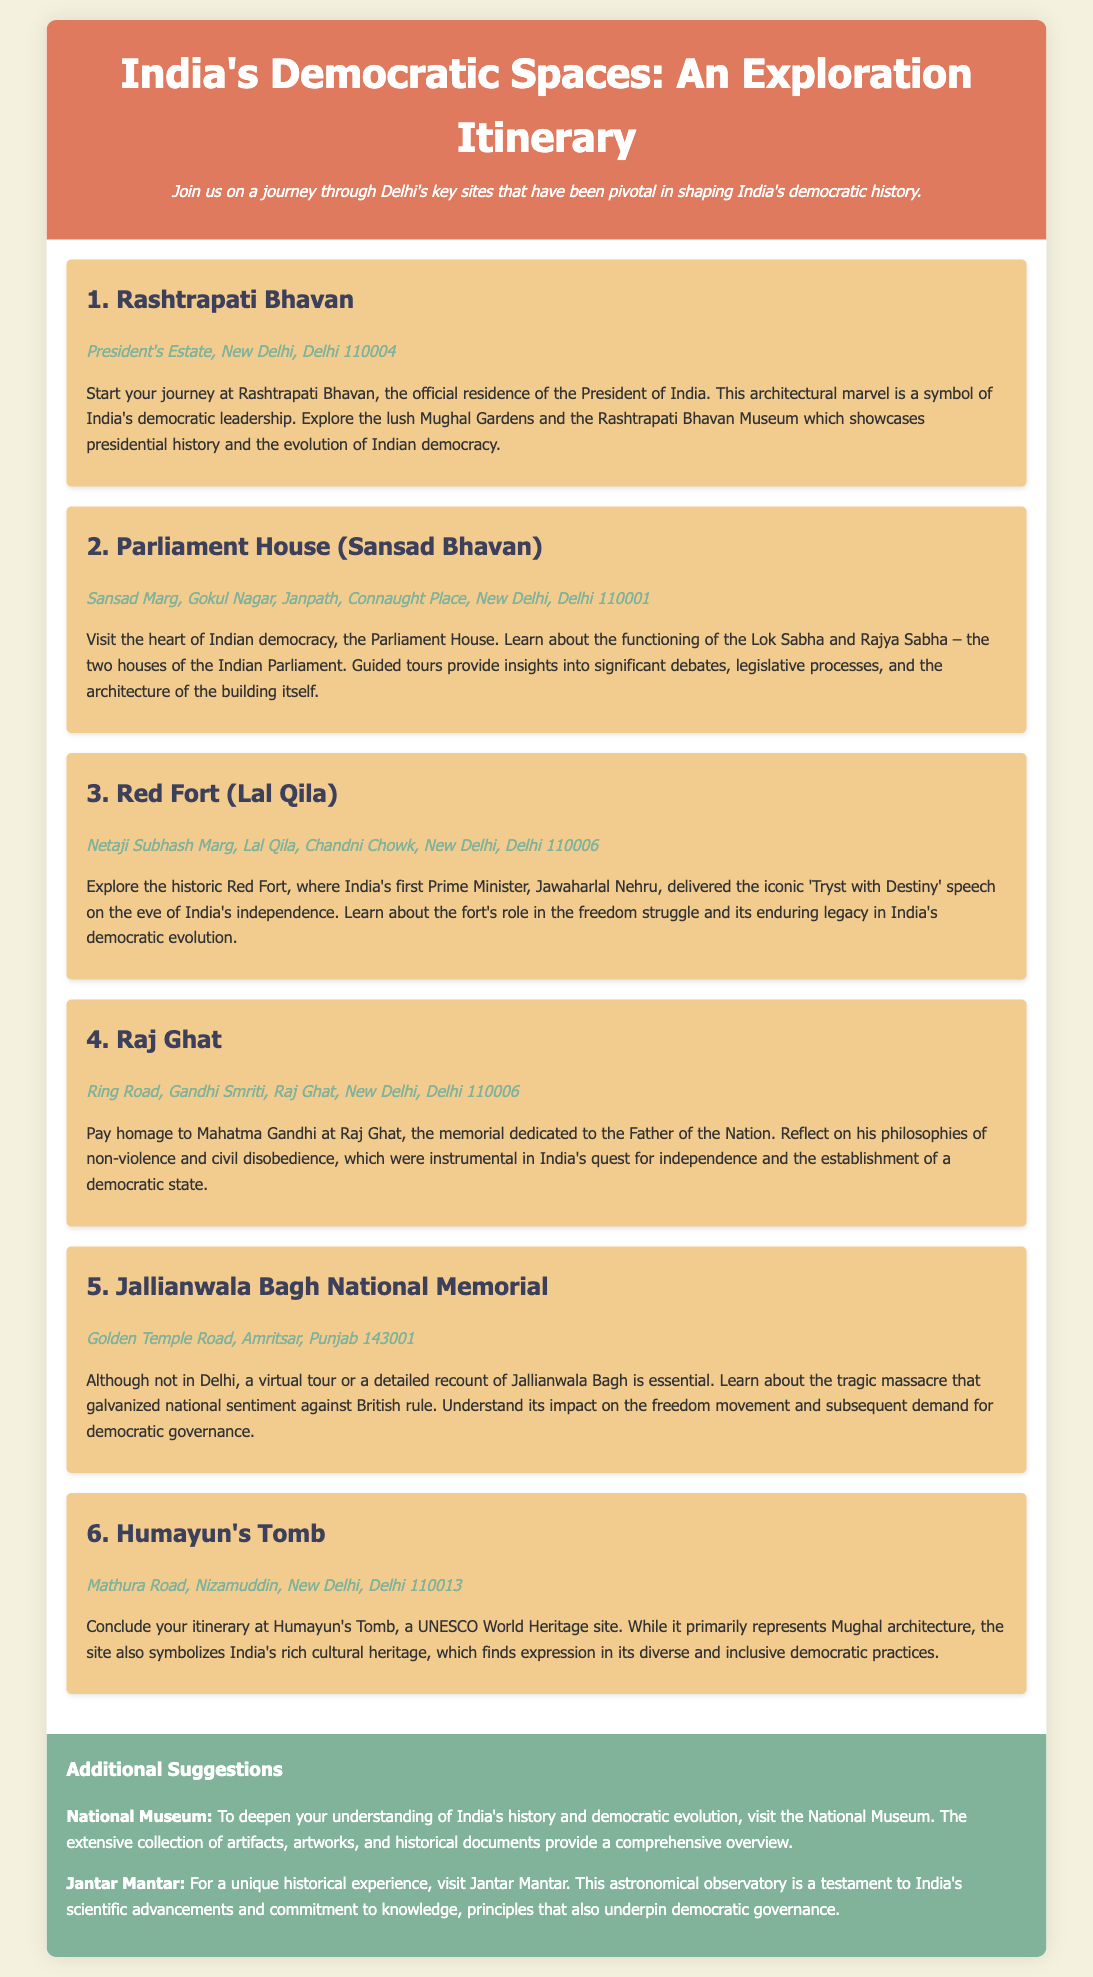What is the address of Rashtrapati Bhavan? The address of Rashtrapati Bhavan is provided in the document as the location of this site during the itinerary.
Answer: President's Estate, New Delhi, Delhi 110004 What is the main function of the Parliament House mentioned in the itinerary? The itinerary describes the Parliament House as the heart of Indian democracy, indicating its fundamental role in governance.
Answer: Governance Where did Jawaharlal Nehru deliver his iconic speech? The document highlights the Red Fort as the site where Nehru's famous speech was made, relevant to India's independence.
Answer: Red Fort What memorial is dedicated to Mahatma Gandhi? The document specifically mentions Raj Ghat as a memorial dedicated to Mahatma Gandhi, providing this key information.
Answer: Raj Ghat How many main sites are included in the itinerary? The total number of sites listed in the itinerary is a key piece of information related to the exploration aspect of the document.
Answer: 6 What architectural style is represented by Humayun's Tomb? The itinerary explicitly states that Humayun's Tomb represents Mughal architecture, thus providing this specific detail.
Answer: Mughal architecture Why is Jallianwala Bagh significant in the freedom struggle? The document explains that Jallianwala Bagh's tragic massacre galvanized national sentiment against British rule, linking it to the fight for democracy.
Answer: National sentiment What additional suggestion is offered to deepen understanding of India's democratic evolution? The document includes a suggestion regarding the National Museum, emphasizing its educational value in understanding democracy.
Answer: National Museum What does the description of the Rashtrapati Bhavan highlight besides its purpose? It mentions the architectural marvel as a symbol of India's democratic leadership, a phrase that captures its dual significance.
Answer: Architectural marvel 